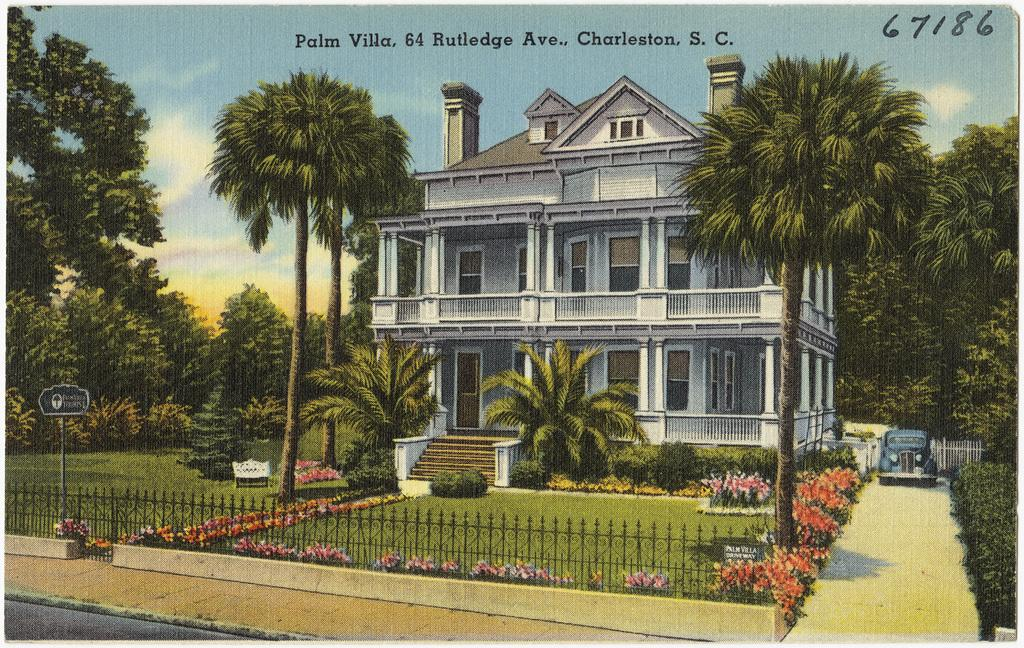What type of structure is visible in the image? There is a building with windows in the image. What can be seen beside the building? There are trees, plants, a fence, a vehicle, a bench, and grass beside the building. What is attached to the side of the building? There is a board beside the building. Is there any indication of the image's origin or ownership? Yes, there is a watermark at the top of the image. Where is the throne located in the image? There is no throne present in the image. Can you hear any animals in the image? The image is silent, and there is no indication of any sounds or animals. 